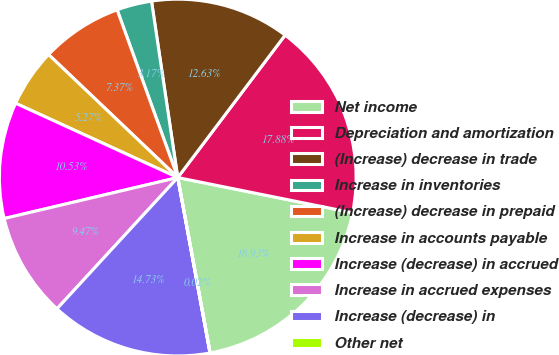<chart> <loc_0><loc_0><loc_500><loc_500><pie_chart><fcel>Net income<fcel>Depreciation and amortization<fcel>(Increase) decrease in trade<fcel>Increase in inventories<fcel>(Increase) decrease in prepaid<fcel>Increase in accounts payable<fcel>Increase (decrease) in accrued<fcel>Increase in accrued expenses<fcel>Increase (decrease) in<fcel>Other net<nl><fcel>18.93%<fcel>17.88%<fcel>12.63%<fcel>3.17%<fcel>7.37%<fcel>5.27%<fcel>10.53%<fcel>9.47%<fcel>14.73%<fcel>0.02%<nl></chart> 